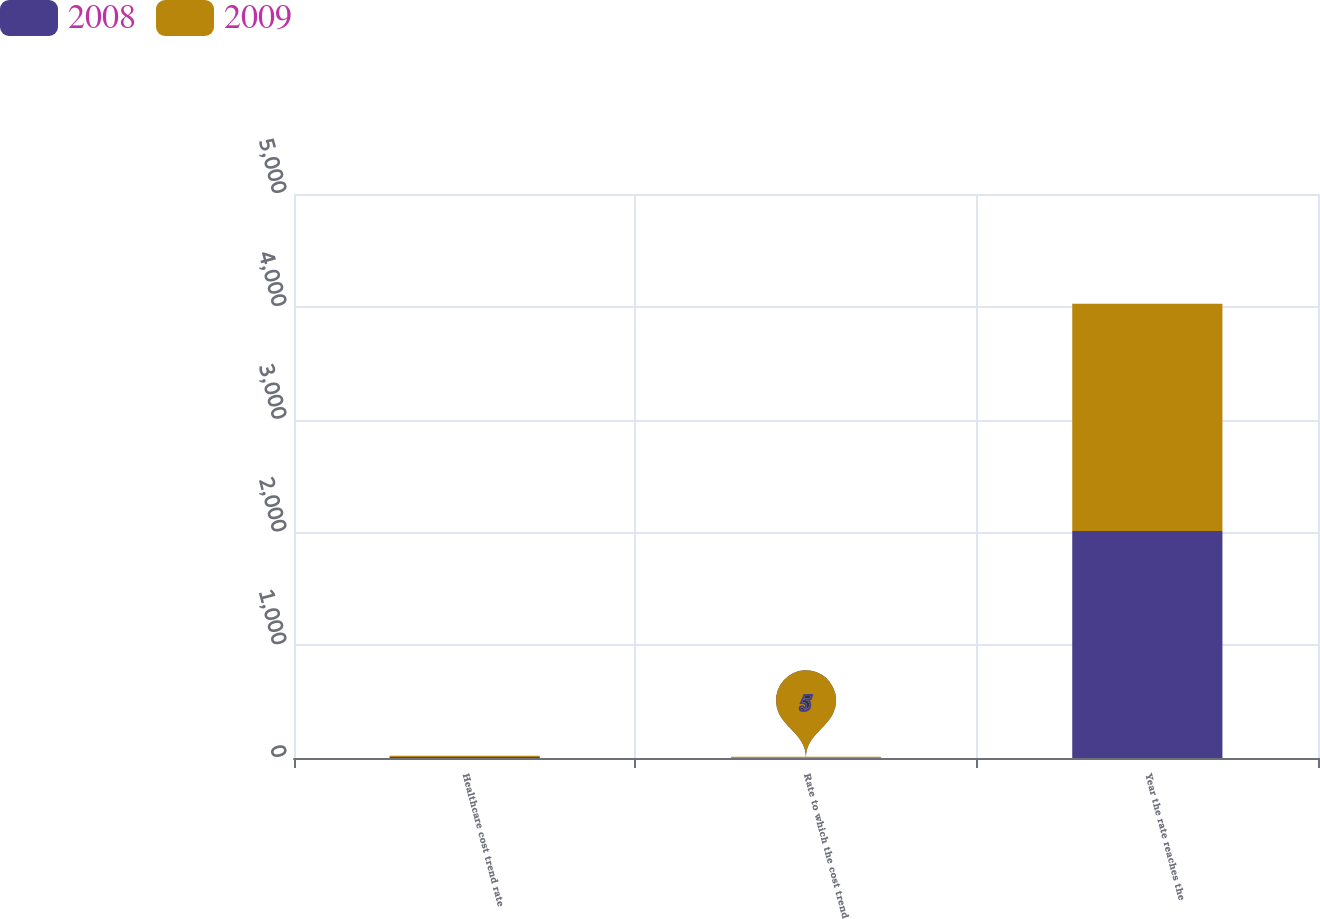Convert chart. <chart><loc_0><loc_0><loc_500><loc_500><stacked_bar_chart><ecel><fcel>Healthcare cost trend rate<fcel>Rate to which the cost trend<fcel>Year the rate reaches the<nl><fcel>2008<fcel>9<fcel>5<fcel>2013<nl><fcel>2009<fcel>10<fcel>5<fcel>2013<nl></chart> 